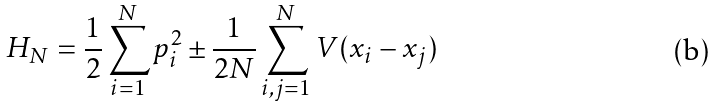Convert formula to latex. <formula><loc_0><loc_0><loc_500><loc_500>H _ { N } = \frac { 1 } { 2 } \sum _ { i = 1 } ^ { N } p _ { i } ^ { 2 } \pm \frac { 1 } { 2 N } \sum _ { i , j = 1 } ^ { N } V ( x _ { i } - x _ { j } )</formula> 